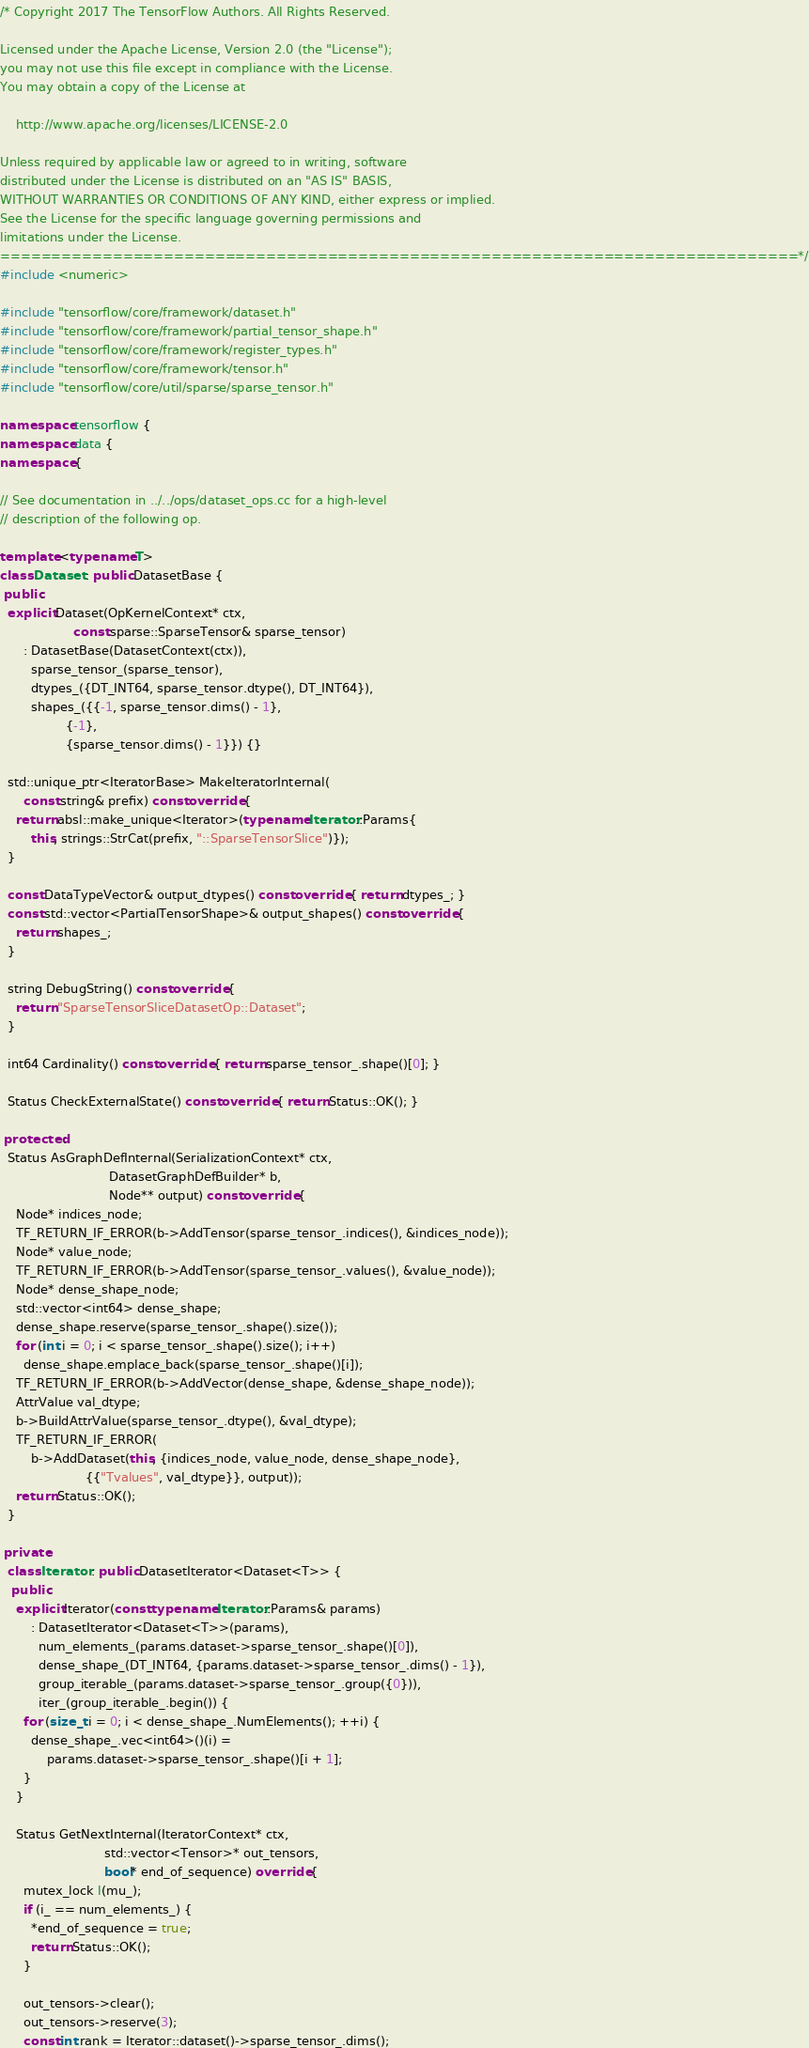<code> <loc_0><loc_0><loc_500><loc_500><_C++_>/* Copyright 2017 The TensorFlow Authors. All Rights Reserved.

Licensed under the Apache License, Version 2.0 (the "License");
you may not use this file except in compliance with the License.
You may obtain a copy of the License at

    http://www.apache.org/licenses/LICENSE-2.0

Unless required by applicable law or agreed to in writing, software
distributed under the License is distributed on an "AS IS" BASIS,
WITHOUT WARRANTIES OR CONDITIONS OF ANY KIND, either express or implied.
See the License for the specific language governing permissions and
limitations under the License.
==============================================================================*/
#include <numeric>

#include "tensorflow/core/framework/dataset.h"
#include "tensorflow/core/framework/partial_tensor_shape.h"
#include "tensorflow/core/framework/register_types.h"
#include "tensorflow/core/framework/tensor.h"
#include "tensorflow/core/util/sparse/sparse_tensor.h"

namespace tensorflow {
namespace data {
namespace {

// See documentation in ../../ops/dataset_ops.cc for a high-level
// description of the following op.

template <typename T>
class Dataset : public DatasetBase {
 public:
  explicit Dataset(OpKernelContext* ctx,
                   const sparse::SparseTensor& sparse_tensor)
      : DatasetBase(DatasetContext(ctx)),
        sparse_tensor_(sparse_tensor),
        dtypes_({DT_INT64, sparse_tensor.dtype(), DT_INT64}),
        shapes_({{-1, sparse_tensor.dims() - 1},
                 {-1},
                 {sparse_tensor.dims() - 1}}) {}

  std::unique_ptr<IteratorBase> MakeIteratorInternal(
      const string& prefix) const override {
    return absl::make_unique<Iterator>(typename Iterator::Params{
        this, strings::StrCat(prefix, "::SparseTensorSlice")});
  }

  const DataTypeVector& output_dtypes() const override { return dtypes_; }
  const std::vector<PartialTensorShape>& output_shapes() const override {
    return shapes_;
  }

  string DebugString() const override {
    return "SparseTensorSliceDatasetOp::Dataset";
  }

  int64 Cardinality() const override { return sparse_tensor_.shape()[0]; }

  Status CheckExternalState() const override { return Status::OK(); }

 protected:
  Status AsGraphDefInternal(SerializationContext* ctx,
                            DatasetGraphDefBuilder* b,
                            Node** output) const override {
    Node* indices_node;
    TF_RETURN_IF_ERROR(b->AddTensor(sparse_tensor_.indices(), &indices_node));
    Node* value_node;
    TF_RETURN_IF_ERROR(b->AddTensor(sparse_tensor_.values(), &value_node));
    Node* dense_shape_node;
    std::vector<int64> dense_shape;
    dense_shape.reserve(sparse_tensor_.shape().size());
    for (int i = 0; i < sparse_tensor_.shape().size(); i++)
      dense_shape.emplace_back(sparse_tensor_.shape()[i]);
    TF_RETURN_IF_ERROR(b->AddVector(dense_shape, &dense_shape_node));
    AttrValue val_dtype;
    b->BuildAttrValue(sparse_tensor_.dtype(), &val_dtype);
    TF_RETURN_IF_ERROR(
        b->AddDataset(this, {indices_node, value_node, dense_shape_node},
                      {{"Tvalues", val_dtype}}, output));
    return Status::OK();
  }

 private:
  class Iterator : public DatasetIterator<Dataset<T>> {
   public:
    explicit Iterator(const typename Iterator::Params& params)
        : DatasetIterator<Dataset<T>>(params),
          num_elements_(params.dataset->sparse_tensor_.shape()[0]),
          dense_shape_(DT_INT64, {params.dataset->sparse_tensor_.dims() - 1}),
          group_iterable_(params.dataset->sparse_tensor_.group({0})),
          iter_(group_iterable_.begin()) {
      for (size_t i = 0; i < dense_shape_.NumElements(); ++i) {
        dense_shape_.vec<int64>()(i) =
            params.dataset->sparse_tensor_.shape()[i + 1];
      }
    }

    Status GetNextInternal(IteratorContext* ctx,
                           std::vector<Tensor>* out_tensors,
                           bool* end_of_sequence) override {
      mutex_lock l(mu_);
      if (i_ == num_elements_) {
        *end_of_sequence = true;
        return Status::OK();
      }

      out_tensors->clear();
      out_tensors->reserve(3);
      const int rank = Iterator::dataset()->sparse_tensor_.dims();
</code> 